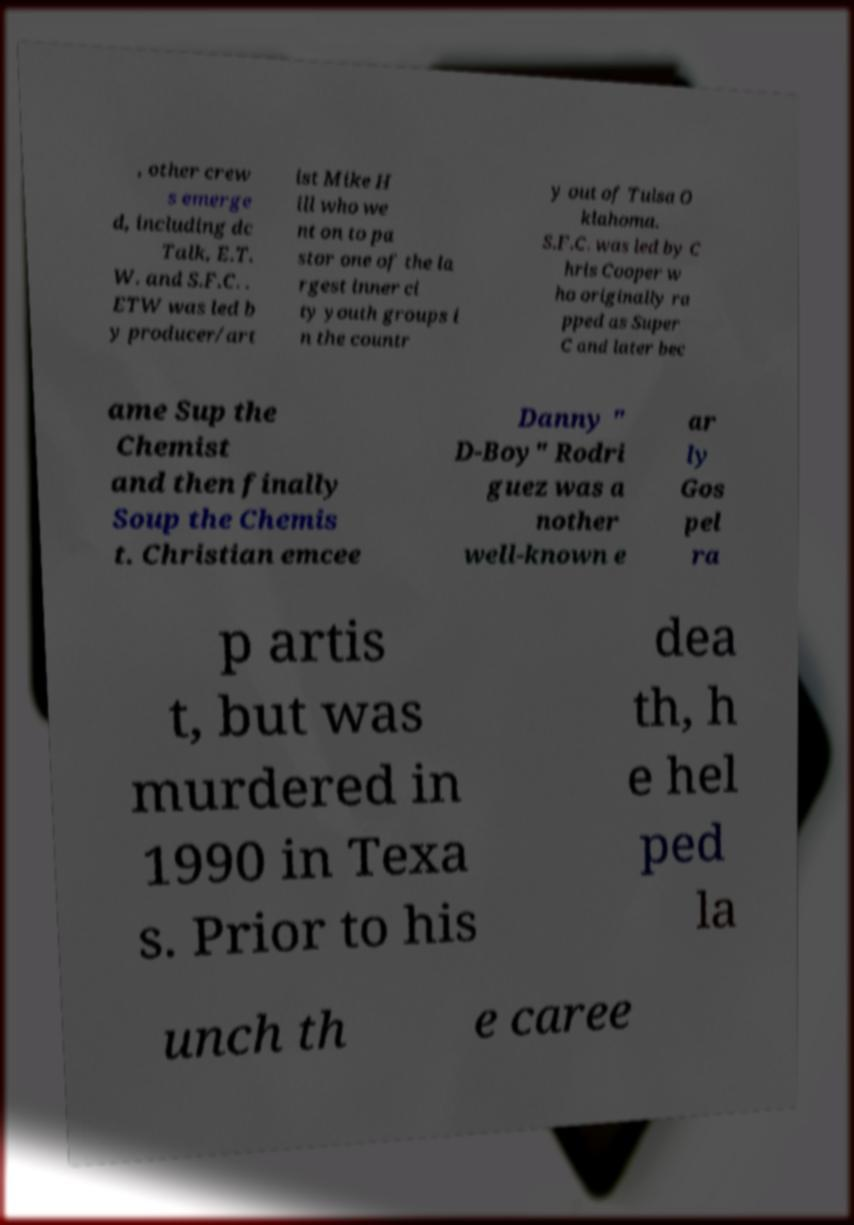I need the written content from this picture converted into text. Can you do that? , other crew s emerge d, including dc Talk, E.T. W. and S.F.C. . ETW was led b y producer/art ist Mike H ill who we nt on to pa stor one of the la rgest inner ci ty youth groups i n the countr y out of Tulsa O klahoma. S.F.C. was led by C hris Cooper w ho originally ra pped as Super C and later bec ame Sup the Chemist and then finally Soup the Chemis t. Christian emcee Danny " D-Boy" Rodri guez was a nother well-known e ar ly Gos pel ra p artis t, but was murdered in 1990 in Texa s. Prior to his dea th, h e hel ped la unch th e caree 